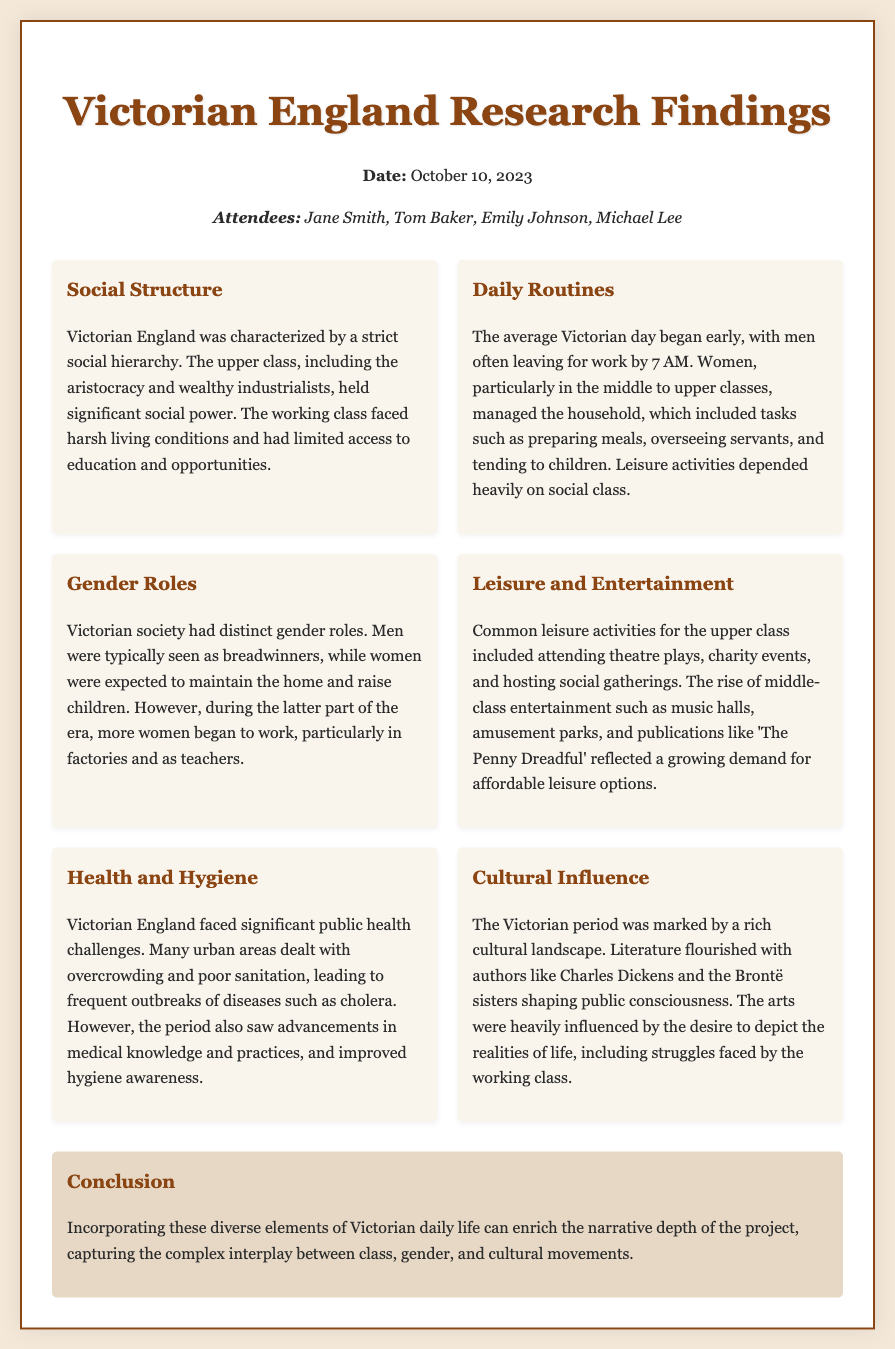What was the date of the meeting? The date of the meeting is stated clearly in the header information of the document.
Answer: October 10, 2023 Who were the attendees of the meeting? The attendees are listed in the header section, providing names of individuals present.
Answer: Jane Smith, Tom Baker, Emily Johnson, Michael Lee What characterized the social structure in Victorian England? The document gives a concise description of the social hierarchy prevalent during the Victorian era.
Answer: Strict social hierarchy At what time did the average Victorian man typically leave for work? The daily routines section specifies the typical behavior of men regarding work start times.
Answer: 7 AM What health challenges did Victorian England face? The health and hygiene section mentions specific public health issues affecting urban areas.
Answer: Overcrowding and poor sanitation What cultural figure is mentioned as having influenced Victorian literature? The cultural influence section provides examples of key authors from the era.
Answer: Charles Dickens What role did women primarily have in Victorian society? The document outlines the expected responsibilities and societal roles of women during this period.
Answer: Maintain the home and raise children What entertainment options were available to the upper class? The leisure and entertainment section describes social activities common among the affluent.
Answer: Theatre plays, charity events, social gatherings How did the Victorian era depict the struggles of the working class? The cultural influence section highlights the portrayal of social issues in the arts.
Answer: Through literature and arts 